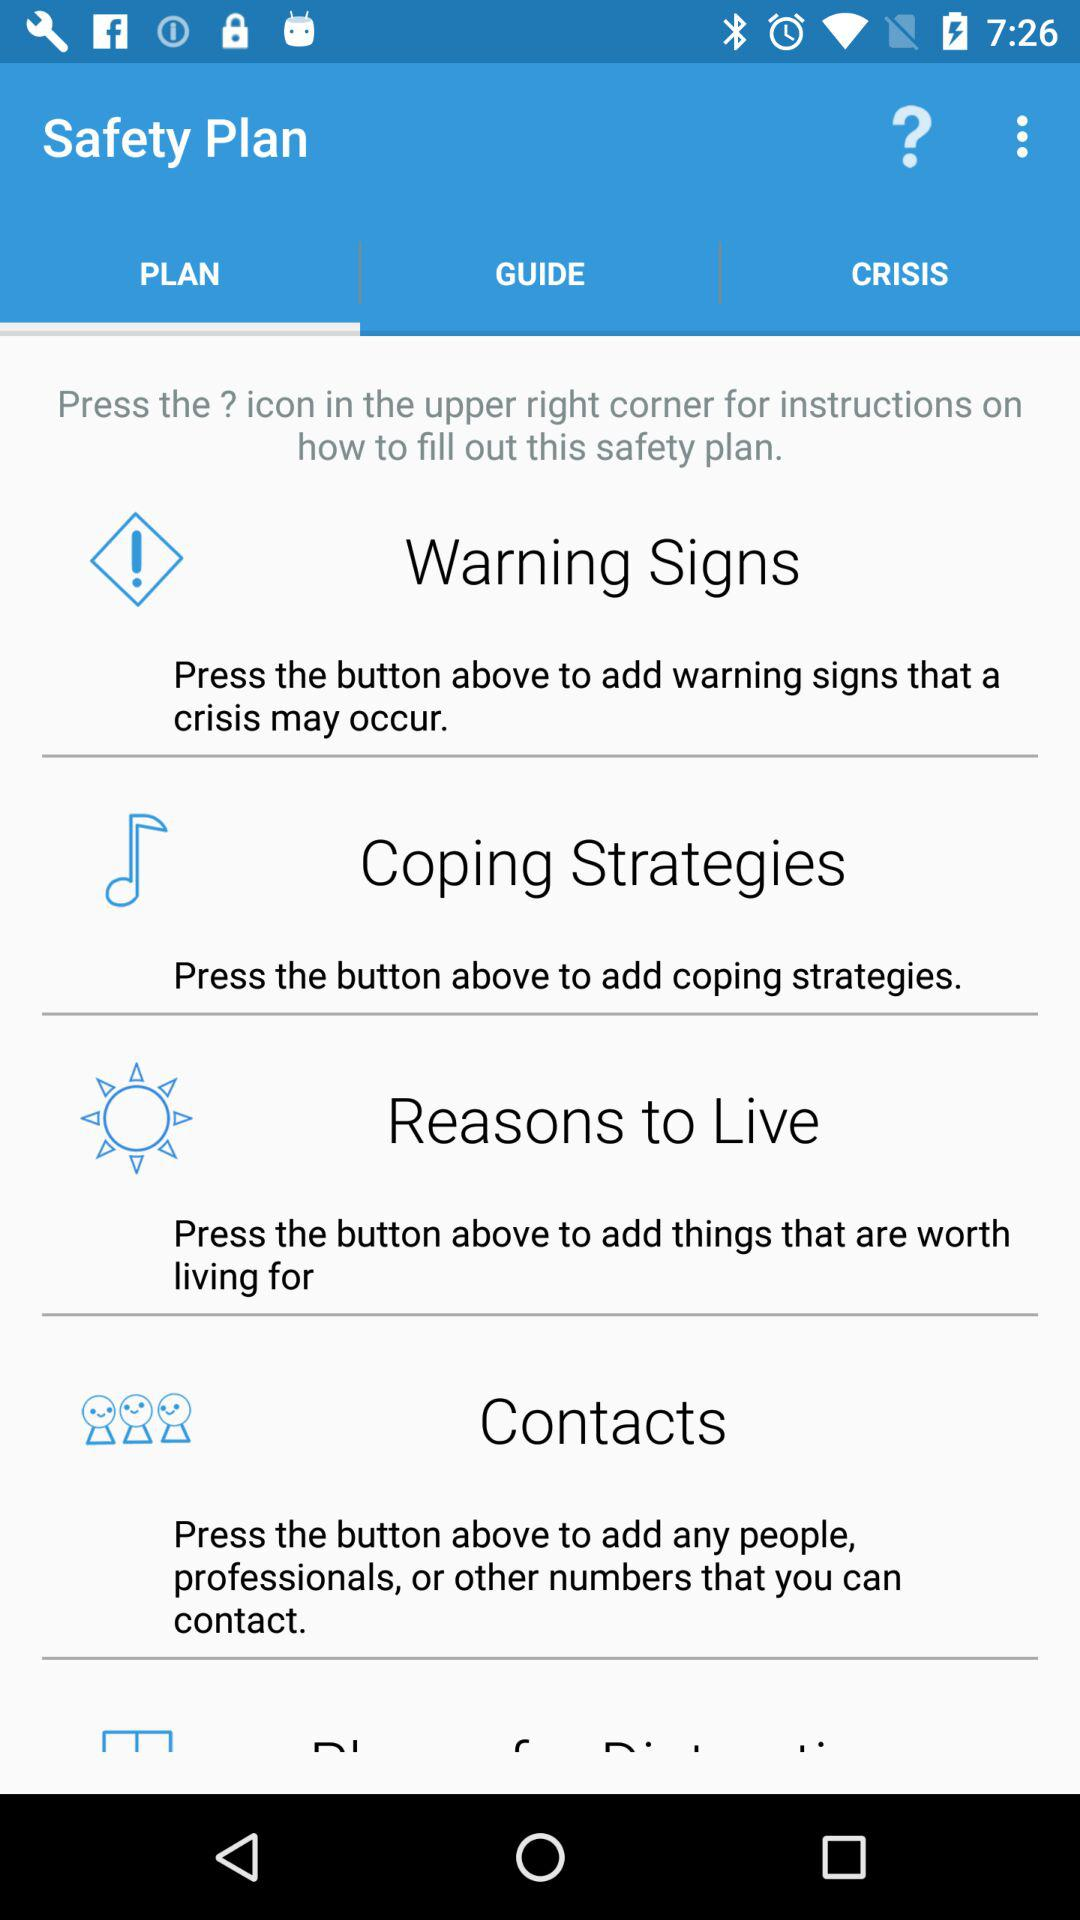Name the safety plan instructions?
When the provided information is insufficient, respond with <no answer>. <no answer> 